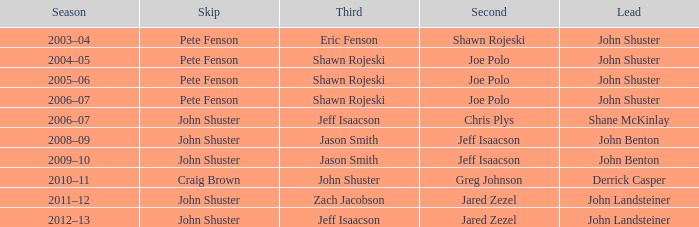Who played the lead role with john shuster serving as skip in the 2009-10 season? John Benton. 